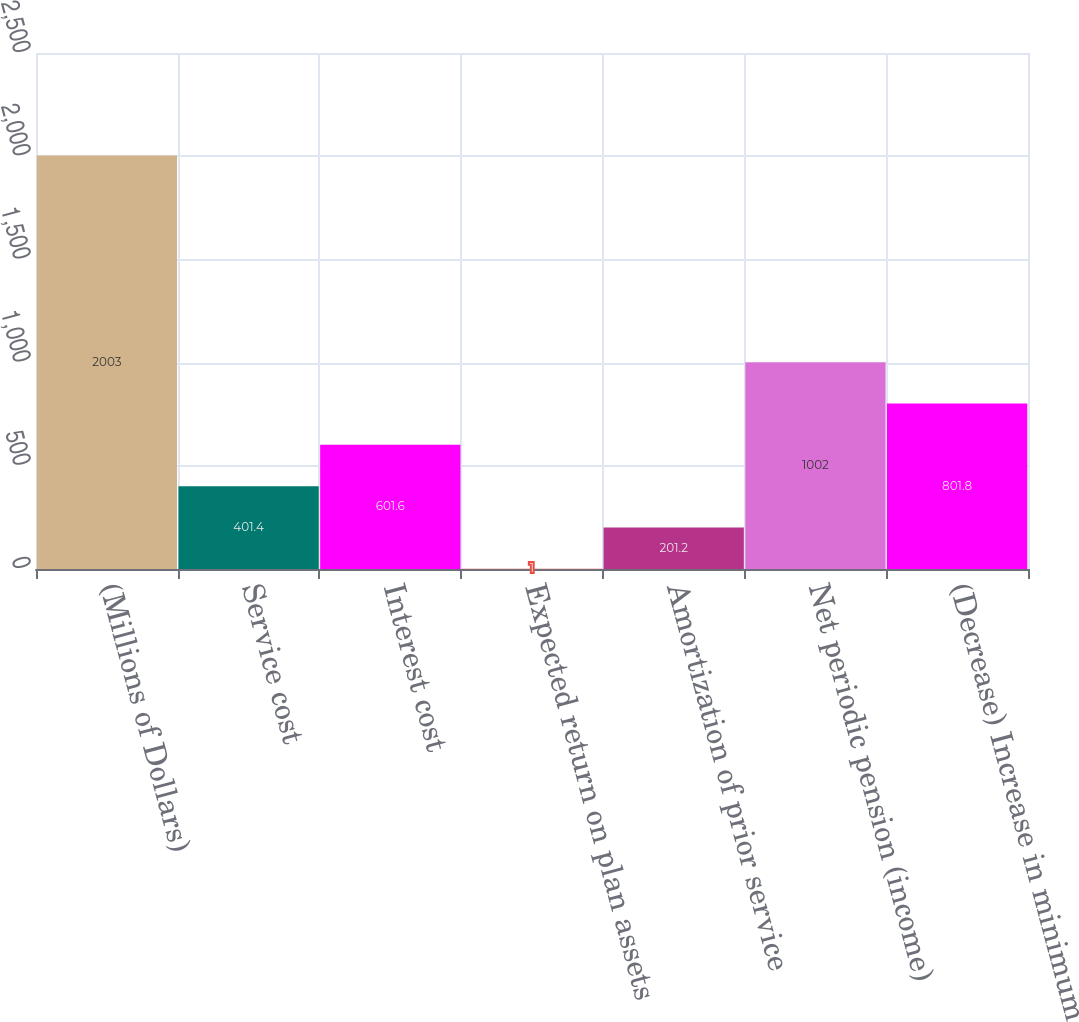Convert chart to OTSL. <chart><loc_0><loc_0><loc_500><loc_500><bar_chart><fcel>(Millions of Dollars)<fcel>Service cost<fcel>Interest cost<fcel>Expected return on plan assets<fcel>Amortization of prior service<fcel>Net periodic pension (income)<fcel>(Decrease) Increase in minimum<nl><fcel>2003<fcel>401.4<fcel>601.6<fcel>1<fcel>201.2<fcel>1002<fcel>801.8<nl></chart> 